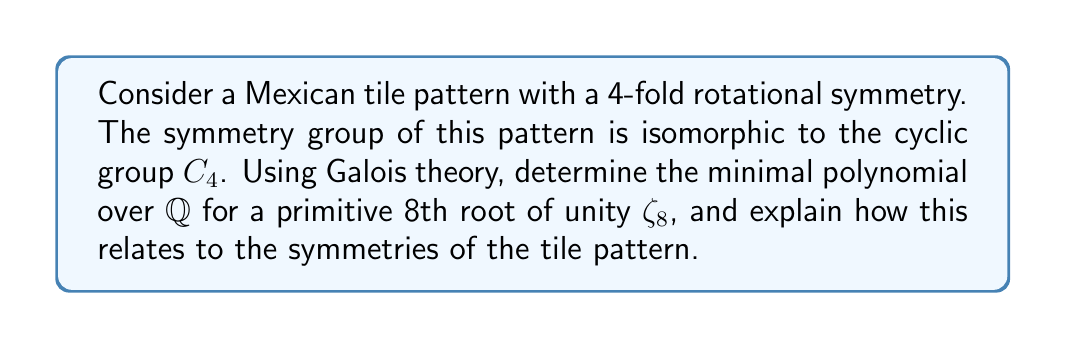Solve this math problem. 1) First, we need to understand that the cyclotomic field $\mathbb{Q}(\zeta_8)$ is the splitting field of $x^8 - 1$ over $\mathbb{Q}$.

2) The Galois group $Gal(\mathbb{Q}(\zeta_8)/\mathbb{Q})$ is isomorphic to $(\mathbb{Z}/8\mathbb{Z})^* \cong C_2 \times C_2$.

3) The minimal polynomial for $\zeta_8$ over $\mathbb{Q}$ is the 4th cyclotomic polynomial:

   $$\Phi_8(x) = x^4 + 1$$

4) This polynomial is irreducible over $\mathbb{Q}$ and has degree 4, which corresponds to the order of the Galois group.

5) The roots of this polynomial are $\zeta_8, \zeta_8^3, \zeta_8^5, \zeta_8^7$, which form a complete set of primitive 8th roots of unity.

6) The symmetry group $C_4$ of the tile pattern is a subgroup of the symmetries of the regular octagon, which is described by the dihedral group $D_8$.

7) The connection between the Galois theory and the tile pattern lies in the fact that the rotational symmetries of the pattern (represented by $C_4$) correspond to a subfield of $\mathbb{Q}(\zeta_8)$ fixed by a subgroup of the Galois group.

8) Specifically, the fixed field of the subgroup $\{\pm 1\} \subset (\mathbb{Z}/8\mathbb{Z})^*$ corresponds to $\mathbb{Q}(\zeta_8 + \zeta_8^{-1})$, which has degree 4 over $\mathbb{Q}$ and Galois group $C_4$.

9) This field contains the coordinates of the vertices of a regular octagon, which can be used to describe the 4-fold symmetry of the tile pattern.
Answer: $x^4 + 1$ 